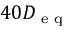Convert formula to latex. <formula><loc_0><loc_0><loc_500><loc_500>4 0 D _ { e q }</formula> 